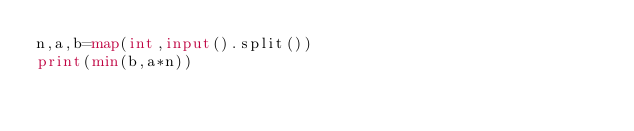<code> <loc_0><loc_0><loc_500><loc_500><_Python_>n,a,b=map(int,input().split())
print(min(b,a*n))
</code> 